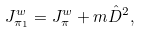<formula> <loc_0><loc_0><loc_500><loc_500>J ^ { w } _ { \pi _ { 1 } } = J ^ { w } _ { \pi } + m \hat { D } ^ { 2 } ,</formula> 